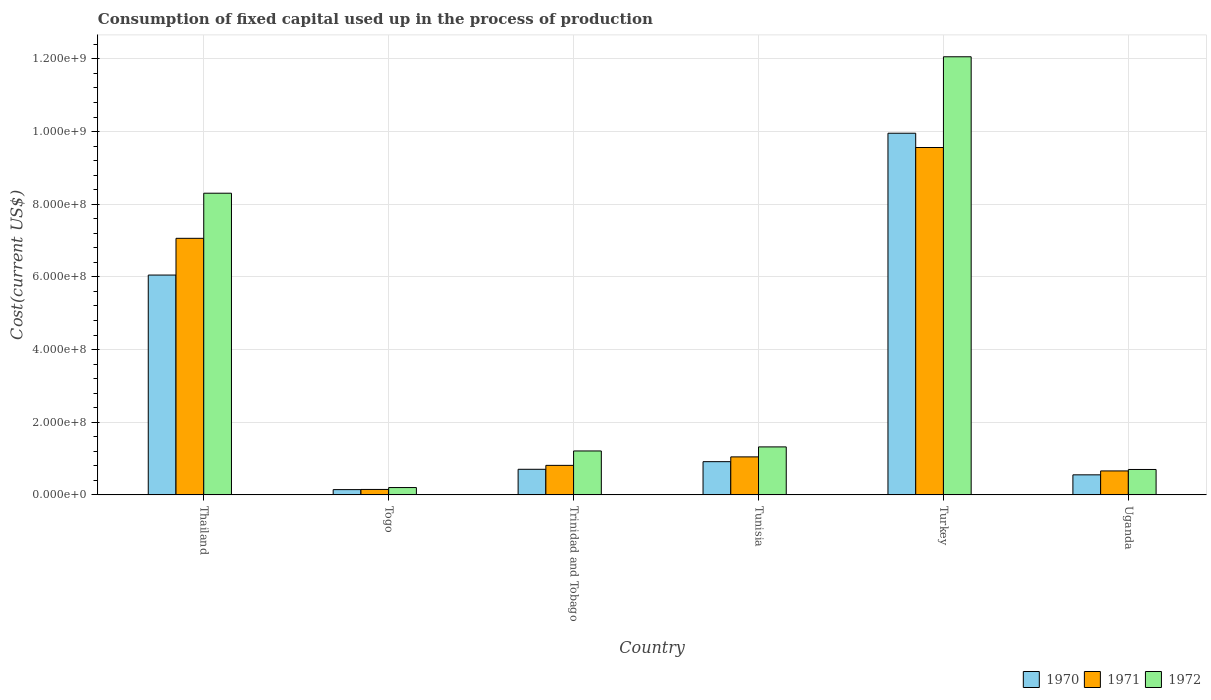How many different coloured bars are there?
Provide a succinct answer. 3. Are the number of bars per tick equal to the number of legend labels?
Ensure brevity in your answer.  Yes. Are the number of bars on each tick of the X-axis equal?
Give a very brief answer. Yes. How many bars are there on the 5th tick from the right?
Ensure brevity in your answer.  3. What is the label of the 1st group of bars from the left?
Ensure brevity in your answer.  Thailand. What is the amount consumed in the process of production in 1970 in Togo?
Provide a short and direct response. 1.45e+07. Across all countries, what is the maximum amount consumed in the process of production in 1972?
Your answer should be compact. 1.21e+09. Across all countries, what is the minimum amount consumed in the process of production in 1971?
Offer a very short reply. 1.50e+07. In which country was the amount consumed in the process of production in 1972 minimum?
Provide a succinct answer. Togo. What is the total amount consumed in the process of production in 1971 in the graph?
Make the answer very short. 1.93e+09. What is the difference between the amount consumed in the process of production in 1971 in Tunisia and that in Turkey?
Make the answer very short. -8.51e+08. What is the difference between the amount consumed in the process of production in 1972 in Tunisia and the amount consumed in the process of production in 1971 in Thailand?
Your response must be concise. -5.74e+08. What is the average amount consumed in the process of production in 1972 per country?
Provide a short and direct response. 3.97e+08. What is the difference between the amount consumed in the process of production of/in 1970 and amount consumed in the process of production of/in 1972 in Thailand?
Offer a terse response. -2.25e+08. What is the ratio of the amount consumed in the process of production in 1971 in Trinidad and Tobago to that in Turkey?
Offer a very short reply. 0.09. Is the amount consumed in the process of production in 1970 in Trinidad and Tobago less than that in Uganda?
Keep it short and to the point. No. Is the difference between the amount consumed in the process of production in 1970 in Trinidad and Tobago and Turkey greater than the difference between the amount consumed in the process of production in 1972 in Trinidad and Tobago and Turkey?
Provide a succinct answer. Yes. What is the difference between the highest and the second highest amount consumed in the process of production in 1971?
Offer a very short reply. 6.02e+08. What is the difference between the highest and the lowest amount consumed in the process of production in 1971?
Make the answer very short. 9.41e+08. What does the 2nd bar from the left in Togo represents?
Ensure brevity in your answer.  1971. What does the 1st bar from the right in Tunisia represents?
Offer a terse response. 1972. How many bars are there?
Provide a succinct answer. 18. Are all the bars in the graph horizontal?
Make the answer very short. No. How many countries are there in the graph?
Your answer should be compact. 6. What is the difference between two consecutive major ticks on the Y-axis?
Provide a succinct answer. 2.00e+08. How many legend labels are there?
Your response must be concise. 3. How are the legend labels stacked?
Your answer should be very brief. Horizontal. What is the title of the graph?
Provide a succinct answer. Consumption of fixed capital used up in the process of production. What is the label or title of the X-axis?
Make the answer very short. Country. What is the label or title of the Y-axis?
Make the answer very short. Cost(current US$). What is the Cost(current US$) in 1970 in Thailand?
Provide a short and direct response. 6.05e+08. What is the Cost(current US$) of 1971 in Thailand?
Your answer should be very brief. 7.06e+08. What is the Cost(current US$) in 1972 in Thailand?
Offer a very short reply. 8.30e+08. What is the Cost(current US$) in 1970 in Togo?
Provide a short and direct response. 1.45e+07. What is the Cost(current US$) in 1971 in Togo?
Provide a succinct answer. 1.50e+07. What is the Cost(current US$) of 1972 in Togo?
Keep it short and to the point. 2.02e+07. What is the Cost(current US$) in 1970 in Trinidad and Tobago?
Give a very brief answer. 7.05e+07. What is the Cost(current US$) in 1971 in Trinidad and Tobago?
Your response must be concise. 8.13e+07. What is the Cost(current US$) of 1972 in Trinidad and Tobago?
Provide a succinct answer. 1.21e+08. What is the Cost(current US$) of 1970 in Tunisia?
Your answer should be compact. 9.14e+07. What is the Cost(current US$) in 1971 in Tunisia?
Offer a very short reply. 1.05e+08. What is the Cost(current US$) of 1972 in Tunisia?
Keep it short and to the point. 1.32e+08. What is the Cost(current US$) in 1970 in Turkey?
Make the answer very short. 9.95e+08. What is the Cost(current US$) of 1971 in Turkey?
Ensure brevity in your answer.  9.56e+08. What is the Cost(current US$) in 1972 in Turkey?
Make the answer very short. 1.21e+09. What is the Cost(current US$) in 1970 in Uganda?
Keep it short and to the point. 5.52e+07. What is the Cost(current US$) in 1971 in Uganda?
Give a very brief answer. 6.60e+07. What is the Cost(current US$) of 1972 in Uganda?
Offer a terse response. 6.99e+07. Across all countries, what is the maximum Cost(current US$) in 1970?
Offer a terse response. 9.95e+08. Across all countries, what is the maximum Cost(current US$) of 1971?
Make the answer very short. 9.56e+08. Across all countries, what is the maximum Cost(current US$) in 1972?
Offer a very short reply. 1.21e+09. Across all countries, what is the minimum Cost(current US$) of 1970?
Provide a succinct answer. 1.45e+07. Across all countries, what is the minimum Cost(current US$) in 1971?
Make the answer very short. 1.50e+07. Across all countries, what is the minimum Cost(current US$) in 1972?
Ensure brevity in your answer.  2.02e+07. What is the total Cost(current US$) of 1970 in the graph?
Keep it short and to the point. 1.83e+09. What is the total Cost(current US$) in 1971 in the graph?
Ensure brevity in your answer.  1.93e+09. What is the total Cost(current US$) of 1972 in the graph?
Provide a succinct answer. 2.38e+09. What is the difference between the Cost(current US$) of 1970 in Thailand and that in Togo?
Make the answer very short. 5.91e+08. What is the difference between the Cost(current US$) of 1971 in Thailand and that in Togo?
Offer a very short reply. 6.91e+08. What is the difference between the Cost(current US$) of 1972 in Thailand and that in Togo?
Your response must be concise. 8.10e+08. What is the difference between the Cost(current US$) in 1970 in Thailand and that in Trinidad and Tobago?
Your answer should be compact. 5.35e+08. What is the difference between the Cost(current US$) of 1971 in Thailand and that in Trinidad and Tobago?
Make the answer very short. 6.25e+08. What is the difference between the Cost(current US$) in 1972 in Thailand and that in Trinidad and Tobago?
Offer a terse response. 7.09e+08. What is the difference between the Cost(current US$) in 1970 in Thailand and that in Tunisia?
Offer a terse response. 5.14e+08. What is the difference between the Cost(current US$) in 1971 in Thailand and that in Tunisia?
Make the answer very short. 6.02e+08. What is the difference between the Cost(current US$) of 1972 in Thailand and that in Tunisia?
Offer a terse response. 6.98e+08. What is the difference between the Cost(current US$) in 1970 in Thailand and that in Turkey?
Your answer should be very brief. -3.90e+08. What is the difference between the Cost(current US$) in 1971 in Thailand and that in Turkey?
Ensure brevity in your answer.  -2.50e+08. What is the difference between the Cost(current US$) in 1972 in Thailand and that in Turkey?
Make the answer very short. -3.75e+08. What is the difference between the Cost(current US$) in 1970 in Thailand and that in Uganda?
Keep it short and to the point. 5.50e+08. What is the difference between the Cost(current US$) in 1971 in Thailand and that in Uganda?
Offer a very short reply. 6.40e+08. What is the difference between the Cost(current US$) in 1972 in Thailand and that in Uganda?
Provide a succinct answer. 7.60e+08. What is the difference between the Cost(current US$) of 1970 in Togo and that in Trinidad and Tobago?
Make the answer very short. -5.59e+07. What is the difference between the Cost(current US$) in 1971 in Togo and that in Trinidad and Tobago?
Offer a terse response. -6.63e+07. What is the difference between the Cost(current US$) of 1972 in Togo and that in Trinidad and Tobago?
Your answer should be compact. -1.01e+08. What is the difference between the Cost(current US$) of 1970 in Togo and that in Tunisia?
Your answer should be very brief. -7.69e+07. What is the difference between the Cost(current US$) of 1971 in Togo and that in Tunisia?
Provide a short and direct response. -8.96e+07. What is the difference between the Cost(current US$) in 1972 in Togo and that in Tunisia?
Offer a very short reply. -1.12e+08. What is the difference between the Cost(current US$) in 1970 in Togo and that in Turkey?
Your response must be concise. -9.81e+08. What is the difference between the Cost(current US$) of 1971 in Togo and that in Turkey?
Provide a short and direct response. -9.41e+08. What is the difference between the Cost(current US$) in 1972 in Togo and that in Turkey?
Your answer should be compact. -1.19e+09. What is the difference between the Cost(current US$) of 1970 in Togo and that in Uganda?
Provide a succinct answer. -4.07e+07. What is the difference between the Cost(current US$) of 1971 in Togo and that in Uganda?
Provide a short and direct response. -5.10e+07. What is the difference between the Cost(current US$) of 1972 in Togo and that in Uganda?
Your answer should be compact. -4.98e+07. What is the difference between the Cost(current US$) of 1970 in Trinidad and Tobago and that in Tunisia?
Your response must be concise. -2.10e+07. What is the difference between the Cost(current US$) in 1971 in Trinidad and Tobago and that in Tunisia?
Provide a short and direct response. -2.34e+07. What is the difference between the Cost(current US$) in 1972 in Trinidad and Tobago and that in Tunisia?
Offer a very short reply. -1.12e+07. What is the difference between the Cost(current US$) in 1970 in Trinidad and Tobago and that in Turkey?
Ensure brevity in your answer.  -9.25e+08. What is the difference between the Cost(current US$) of 1971 in Trinidad and Tobago and that in Turkey?
Provide a short and direct response. -8.75e+08. What is the difference between the Cost(current US$) of 1972 in Trinidad and Tobago and that in Turkey?
Keep it short and to the point. -1.08e+09. What is the difference between the Cost(current US$) of 1970 in Trinidad and Tobago and that in Uganda?
Make the answer very short. 1.52e+07. What is the difference between the Cost(current US$) in 1971 in Trinidad and Tobago and that in Uganda?
Provide a short and direct response. 1.53e+07. What is the difference between the Cost(current US$) of 1972 in Trinidad and Tobago and that in Uganda?
Provide a succinct answer. 5.10e+07. What is the difference between the Cost(current US$) of 1970 in Tunisia and that in Turkey?
Ensure brevity in your answer.  -9.04e+08. What is the difference between the Cost(current US$) in 1971 in Tunisia and that in Turkey?
Provide a short and direct response. -8.51e+08. What is the difference between the Cost(current US$) in 1972 in Tunisia and that in Turkey?
Give a very brief answer. -1.07e+09. What is the difference between the Cost(current US$) of 1970 in Tunisia and that in Uganda?
Your response must be concise. 3.62e+07. What is the difference between the Cost(current US$) of 1971 in Tunisia and that in Uganda?
Make the answer very short. 3.87e+07. What is the difference between the Cost(current US$) of 1972 in Tunisia and that in Uganda?
Keep it short and to the point. 6.21e+07. What is the difference between the Cost(current US$) in 1970 in Turkey and that in Uganda?
Keep it short and to the point. 9.40e+08. What is the difference between the Cost(current US$) of 1971 in Turkey and that in Uganda?
Make the answer very short. 8.90e+08. What is the difference between the Cost(current US$) in 1972 in Turkey and that in Uganda?
Your answer should be very brief. 1.14e+09. What is the difference between the Cost(current US$) in 1970 in Thailand and the Cost(current US$) in 1971 in Togo?
Give a very brief answer. 5.90e+08. What is the difference between the Cost(current US$) in 1970 in Thailand and the Cost(current US$) in 1972 in Togo?
Your response must be concise. 5.85e+08. What is the difference between the Cost(current US$) of 1971 in Thailand and the Cost(current US$) of 1972 in Togo?
Your answer should be very brief. 6.86e+08. What is the difference between the Cost(current US$) of 1970 in Thailand and the Cost(current US$) of 1971 in Trinidad and Tobago?
Provide a short and direct response. 5.24e+08. What is the difference between the Cost(current US$) of 1970 in Thailand and the Cost(current US$) of 1972 in Trinidad and Tobago?
Your response must be concise. 4.84e+08. What is the difference between the Cost(current US$) of 1971 in Thailand and the Cost(current US$) of 1972 in Trinidad and Tobago?
Offer a terse response. 5.85e+08. What is the difference between the Cost(current US$) in 1970 in Thailand and the Cost(current US$) in 1971 in Tunisia?
Provide a short and direct response. 5.00e+08. What is the difference between the Cost(current US$) of 1970 in Thailand and the Cost(current US$) of 1972 in Tunisia?
Your response must be concise. 4.73e+08. What is the difference between the Cost(current US$) in 1971 in Thailand and the Cost(current US$) in 1972 in Tunisia?
Your answer should be compact. 5.74e+08. What is the difference between the Cost(current US$) in 1970 in Thailand and the Cost(current US$) in 1971 in Turkey?
Offer a very short reply. -3.51e+08. What is the difference between the Cost(current US$) of 1970 in Thailand and the Cost(current US$) of 1972 in Turkey?
Offer a very short reply. -6.01e+08. What is the difference between the Cost(current US$) of 1971 in Thailand and the Cost(current US$) of 1972 in Turkey?
Ensure brevity in your answer.  -5.00e+08. What is the difference between the Cost(current US$) of 1970 in Thailand and the Cost(current US$) of 1971 in Uganda?
Make the answer very short. 5.39e+08. What is the difference between the Cost(current US$) of 1970 in Thailand and the Cost(current US$) of 1972 in Uganda?
Keep it short and to the point. 5.35e+08. What is the difference between the Cost(current US$) in 1971 in Thailand and the Cost(current US$) in 1972 in Uganda?
Your answer should be compact. 6.36e+08. What is the difference between the Cost(current US$) in 1970 in Togo and the Cost(current US$) in 1971 in Trinidad and Tobago?
Give a very brief answer. -6.67e+07. What is the difference between the Cost(current US$) of 1970 in Togo and the Cost(current US$) of 1972 in Trinidad and Tobago?
Provide a short and direct response. -1.06e+08. What is the difference between the Cost(current US$) of 1971 in Togo and the Cost(current US$) of 1972 in Trinidad and Tobago?
Offer a very short reply. -1.06e+08. What is the difference between the Cost(current US$) of 1970 in Togo and the Cost(current US$) of 1971 in Tunisia?
Make the answer very short. -9.01e+07. What is the difference between the Cost(current US$) of 1970 in Togo and the Cost(current US$) of 1972 in Tunisia?
Your answer should be very brief. -1.18e+08. What is the difference between the Cost(current US$) of 1971 in Togo and the Cost(current US$) of 1972 in Tunisia?
Keep it short and to the point. -1.17e+08. What is the difference between the Cost(current US$) of 1970 in Togo and the Cost(current US$) of 1971 in Turkey?
Your answer should be very brief. -9.42e+08. What is the difference between the Cost(current US$) in 1970 in Togo and the Cost(current US$) in 1972 in Turkey?
Provide a short and direct response. -1.19e+09. What is the difference between the Cost(current US$) of 1971 in Togo and the Cost(current US$) of 1972 in Turkey?
Offer a very short reply. -1.19e+09. What is the difference between the Cost(current US$) in 1970 in Togo and the Cost(current US$) in 1971 in Uganda?
Offer a terse response. -5.14e+07. What is the difference between the Cost(current US$) in 1970 in Togo and the Cost(current US$) in 1972 in Uganda?
Make the answer very short. -5.54e+07. What is the difference between the Cost(current US$) in 1971 in Togo and the Cost(current US$) in 1972 in Uganda?
Offer a terse response. -5.50e+07. What is the difference between the Cost(current US$) in 1970 in Trinidad and Tobago and the Cost(current US$) in 1971 in Tunisia?
Keep it short and to the point. -3.42e+07. What is the difference between the Cost(current US$) of 1970 in Trinidad and Tobago and the Cost(current US$) of 1972 in Tunisia?
Your response must be concise. -6.16e+07. What is the difference between the Cost(current US$) in 1971 in Trinidad and Tobago and the Cost(current US$) in 1972 in Tunisia?
Your response must be concise. -5.08e+07. What is the difference between the Cost(current US$) of 1970 in Trinidad and Tobago and the Cost(current US$) of 1971 in Turkey?
Offer a very short reply. -8.86e+08. What is the difference between the Cost(current US$) in 1970 in Trinidad and Tobago and the Cost(current US$) in 1972 in Turkey?
Offer a very short reply. -1.14e+09. What is the difference between the Cost(current US$) in 1971 in Trinidad and Tobago and the Cost(current US$) in 1972 in Turkey?
Your answer should be very brief. -1.12e+09. What is the difference between the Cost(current US$) of 1970 in Trinidad and Tobago and the Cost(current US$) of 1971 in Uganda?
Offer a terse response. 4.50e+06. What is the difference between the Cost(current US$) of 1970 in Trinidad and Tobago and the Cost(current US$) of 1972 in Uganda?
Provide a succinct answer. 5.21e+05. What is the difference between the Cost(current US$) of 1971 in Trinidad and Tobago and the Cost(current US$) of 1972 in Uganda?
Provide a succinct answer. 1.13e+07. What is the difference between the Cost(current US$) of 1970 in Tunisia and the Cost(current US$) of 1971 in Turkey?
Keep it short and to the point. -8.65e+08. What is the difference between the Cost(current US$) of 1970 in Tunisia and the Cost(current US$) of 1972 in Turkey?
Your answer should be very brief. -1.11e+09. What is the difference between the Cost(current US$) of 1971 in Tunisia and the Cost(current US$) of 1972 in Turkey?
Keep it short and to the point. -1.10e+09. What is the difference between the Cost(current US$) of 1970 in Tunisia and the Cost(current US$) of 1971 in Uganda?
Offer a terse response. 2.55e+07. What is the difference between the Cost(current US$) in 1970 in Tunisia and the Cost(current US$) in 1972 in Uganda?
Provide a succinct answer. 2.15e+07. What is the difference between the Cost(current US$) of 1971 in Tunisia and the Cost(current US$) of 1972 in Uganda?
Provide a succinct answer. 3.47e+07. What is the difference between the Cost(current US$) of 1970 in Turkey and the Cost(current US$) of 1971 in Uganda?
Make the answer very short. 9.29e+08. What is the difference between the Cost(current US$) of 1970 in Turkey and the Cost(current US$) of 1972 in Uganda?
Give a very brief answer. 9.25e+08. What is the difference between the Cost(current US$) in 1971 in Turkey and the Cost(current US$) in 1972 in Uganda?
Offer a terse response. 8.86e+08. What is the average Cost(current US$) in 1970 per country?
Your answer should be very brief. 3.05e+08. What is the average Cost(current US$) of 1971 per country?
Your answer should be compact. 3.22e+08. What is the average Cost(current US$) in 1972 per country?
Your answer should be compact. 3.97e+08. What is the difference between the Cost(current US$) of 1970 and Cost(current US$) of 1971 in Thailand?
Give a very brief answer. -1.01e+08. What is the difference between the Cost(current US$) in 1970 and Cost(current US$) in 1972 in Thailand?
Your answer should be very brief. -2.25e+08. What is the difference between the Cost(current US$) in 1971 and Cost(current US$) in 1972 in Thailand?
Offer a terse response. -1.24e+08. What is the difference between the Cost(current US$) of 1970 and Cost(current US$) of 1971 in Togo?
Offer a very short reply. -4.75e+05. What is the difference between the Cost(current US$) of 1970 and Cost(current US$) of 1972 in Togo?
Offer a terse response. -5.68e+06. What is the difference between the Cost(current US$) of 1971 and Cost(current US$) of 1972 in Togo?
Give a very brief answer. -5.20e+06. What is the difference between the Cost(current US$) in 1970 and Cost(current US$) in 1971 in Trinidad and Tobago?
Ensure brevity in your answer.  -1.08e+07. What is the difference between the Cost(current US$) in 1970 and Cost(current US$) in 1972 in Trinidad and Tobago?
Keep it short and to the point. -5.04e+07. What is the difference between the Cost(current US$) of 1971 and Cost(current US$) of 1972 in Trinidad and Tobago?
Your answer should be very brief. -3.96e+07. What is the difference between the Cost(current US$) of 1970 and Cost(current US$) of 1971 in Tunisia?
Keep it short and to the point. -1.32e+07. What is the difference between the Cost(current US$) in 1970 and Cost(current US$) in 1972 in Tunisia?
Offer a terse response. -4.06e+07. What is the difference between the Cost(current US$) in 1971 and Cost(current US$) in 1972 in Tunisia?
Offer a very short reply. -2.75e+07. What is the difference between the Cost(current US$) in 1970 and Cost(current US$) in 1971 in Turkey?
Make the answer very short. 3.93e+07. What is the difference between the Cost(current US$) in 1970 and Cost(current US$) in 1972 in Turkey?
Keep it short and to the point. -2.10e+08. What is the difference between the Cost(current US$) in 1971 and Cost(current US$) in 1972 in Turkey?
Give a very brief answer. -2.50e+08. What is the difference between the Cost(current US$) in 1970 and Cost(current US$) in 1971 in Uganda?
Offer a very short reply. -1.07e+07. What is the difference between the Cost(current US$) in 1970 and Cost(current US$) in 1972 in Uganda?
Provide a short and direct response. -1.47e+07. What is the difference between the Cost(current US$) of 1971 and Cost(current US$) of 1972 in Uganda?
Give a very brief answer. -3.98e+06. What is the ratio of the Cost(current US$) of 1970 in Thailand to that in Togo?
Your response must be concise. 41.67. What is the ratio of the Cost(current US$) of 1971 in Thailand to that in Togo?
Give a very brief answer. 47.09. What is the ratio of the Cost(current US$) of 1972 in Thailand to that in Togo?
Provide a short and direct response. 41.11. What is the ratio of the Cost(current US$) in 1970 in Thailand to that in Trinidad and Tobago?
Give a very brief answer. 8.59. What is the ratio of the Cost(current US$) of 1971 in Thailand to that in Trinidad and Tobago?
Offer a terse response. 8.69. What is the ratio of the Cost(current US$) in 1972 in Thailand to that in Trinidad and Tobago?
Provide a succinct answer. 6.87. What is the ratio of the Cost(current US$) of 1970 in Thailand to that in Tunisia?
Keep it short and to the point. 6.62. What is the ratio of the Cost(current US$) of 1971 in Thailand to that in Tunisia?
Keep it short and to the point. 6.75. What is the ratio of the Cost(current US$) in 1972 in Thailand to that in Tunisia?
Provide a short and direct response. 6.29. What is the ratio of the Cost(current US$) in 1970 in Thailand to that in Turkey?
Your answer should be very brief. 0.61. What is the ratio of the Cost(current US$) of 1971 in Thailand to that in Turkey?
Offer a terse response. 0.74. What is the ratio of the Cost(current US$) in 1972 in Thailand to that in Turkey?
Give a very brief answer. 0.69. What is the ratio of the Cost(current US$) of 1970 in Thailand to that in Uganda?
Your answer should be very brief. 10.96. What is the ratio of the Cost(current US$) in 1971 in Thailand to that in Uganda?
Ensure brevity in your answer.  10.71. What is the ratio of the Cost(current US$) of 1972 in Thailand to that in Uganda?
Offer a very short reply. 11.87. What is the ratio of the Cost(current US$) in 1970 in Togo to that in Trinidad and Tobago?
Ensure brevity in your answer.  0.21. What is the ratio of the Cost(current US$) of 1971 in Togo to that in Trinidad and Tobago?
Your answer should be compact. 0.18. What is the ratio of the Cost(current US$) of 1972 in Togo to that in Trinidad and Tobago?
Your answer should be compact. 0.17. What is the ratio of the Cost(current US$) in 1970 in Togo to that in Tunisia?
Your response must be concise. 0.16. What is the ratio of the Cost(current US$) in 1971 in Togo to that in Tunisia?
Provide a succinct answer. 0.14. What is the ratio of the Cost(current US$) of 1972 in Togo to that in Tunisia?
Make the answer very short. 0.15. What is the ratio of the Cost(current US$) in 1970 in Togo to that in Turkey?
Make the answer very short. 0.01. What is the ratio of the Cost(current US$) of 1971 in Togo to that in Turkey?
Your answer should be very brief. 0.02. What is the ratio of the Cost(current US$) of 1972 in Togo to that in Turkey?
Provide a short and direct response. 0.02. What is the ratio of the Cost(current US$) of 1970 in Togo to that in Uganda?
Make the answer very short. 0.26. What is the ratio of the Cost(current US$) of 1971 in Togo to that in Uganda?
Provide a succinct answer. 0.23. What is the ratio of the Cost(current US$) of 1972 in Togo to that in Uganda?
Give a very brief answer. 0.29. What is the ratio of the Cost(current US$) of 1970 in Trinidad and Tobago to that in Tunisia?
Ensure brevity in your answer.  0.77. What is the ratio of the Cost(current US$) of 1971 in Trinidad and Tobago to that in Tunisia?
Keep it short and to the point. 0.78. What is the ratio of the Cost(current US$) of 1972 in Trinidad and Tobago to that in Tunisia?
Provide a succinct answer. 0.92. What is the ratio of the Cost(current US$) in 1970 in Trinidad and Tobago to that in Turkey?
Keep it short and to the point. 0.07. What is the ratio of the Cost(current US$) of 1971 in Trinidad and Tobago to that in Turkey?
Keep it short and to the point. 0.09. What is the ratio of the Cost(current US$) of 1972 in Trinidad and Tobago to that in Turkey?
Offer a very short reply. 0.1. What is the ratio of the Cost(current US$) in 1970 in Trinidad and Tobago to that in Uganda?
Ensure brevity in your answer.  1.28. What is the ratio of the Cost(current US$) of 1971 in Trinidad and Tobago to that in Uganda?
Give a very brief answer. 1.23. What is the ratio of the Cost(current US$) in 1972 in Trinidad and Tobago to that in Uganda?
Provide a succinct answer. 1.73. What is the ratio of the Cost(current US$) in 1970 in Tunisia to that in Turkey?
Give a very brief answer. 0.09. What is the ratio of the Cost(current US$) of 1971 in Tunisia to that in Turkey?
Keep it short and to the point. 0.11. What is the ratio of the Cost(current US$) of 1972 in Tunisia to that in Turkey?
Offer a terse response. 0.11. What is the ratio of the Cost(current US$) of 1970 in Tunisia to that in Uganda?
Provide a short and direct response. 1.66. What is the ratio of the Cost(current US$) in 1971 in Tunisia to that in Uganda?
Your answer should be very brief. 1.59. What is the ratio of the Cost(current US$) of 1972 in Tunisia to that in Uganda?
Give a very brief answer. 1.89. What is the ratio of the Cost(current US$) in 1970 in Turkey to that in Uganda?
Your answer should be compact. 18.02. What is the ratio of the Cost(current US$) in 1971 in Turkey to that in Uganda?
Your answer should be very brief. 14.49. What is the ratio of the Cost(current US$) in 1972 in Turkey to that in Uganda?
Provide a succinct answer. 17.24. What is the difference between the highest and the second highest Cost(current US$) of 1970?
Your response must be concise. 3.90e+08. What is the difference between the highest and the second highest Cost(current US$) in 1971?
Ensure brevity in your answer.  2.50e+08. What is the difference between the highest and the second highest Cost(current US$) in 1972?
Make the answer very short. 3.75e+08. What is the difference between the highest and the lowest Cost(current US$) of 1970?
Your answer should be very brief. 9.81e+08. What is the difference between the highest and the lowest Cost(current US$) in 1971?
Give a very brief answer. 9.41e+08. What is the difference between the highest and the lowest Cost(current US$) in 1972?
Your answer should be compact. 1.19e+09. 